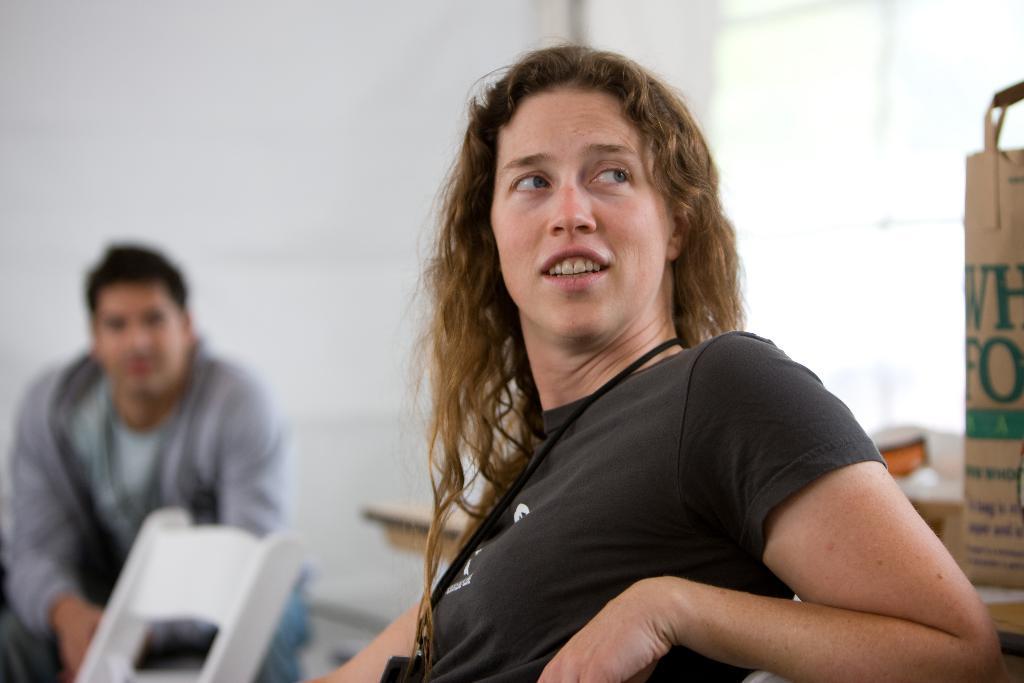How would you summarize this image in a sentence or two? In this image I can see a woman and I can see she is wearing black t shirt. In the background I can see a white chair and I can see a man is sitting. I can also see this image is little bit blurry from background. Here on this bag I can see something is written. 